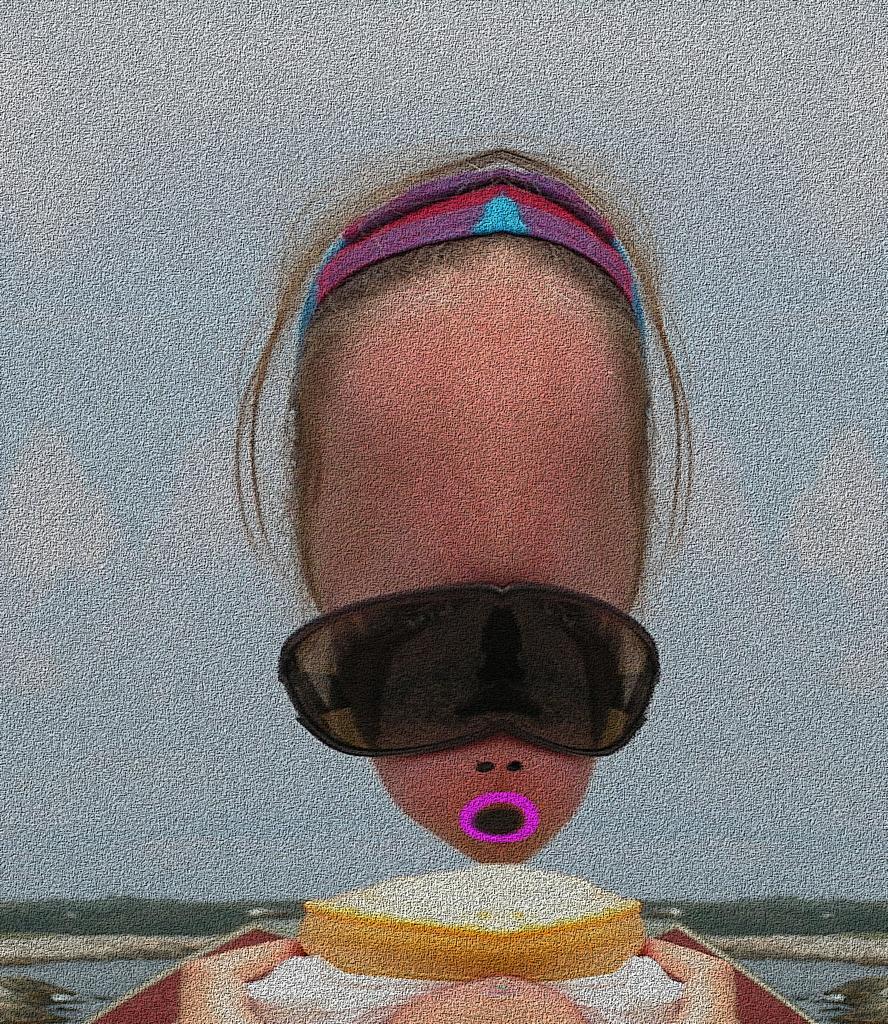In one or two sentences, can you explain what this image depicts? This picture is an edited picture. In this picture there is a person with goggles. At the back there are trees. At the top there is sky. At the bottom there is water. 